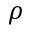Convert formula to latex. <formula><loc_0><loc_0><loc_500><loc_500>\rho</formula> 